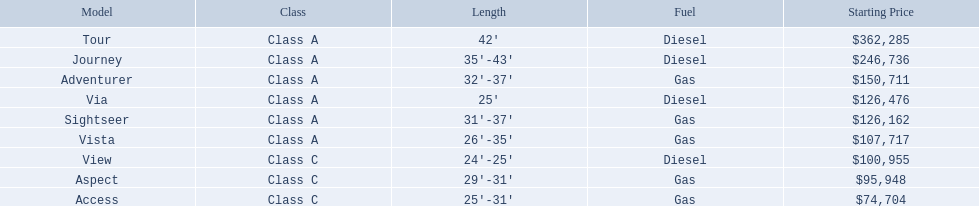What varieties of winnebago models are available? Tour, Journey, Adventurer, Via, Sightseer, Vista, View, Aspect, Access. Which ones are diesel-powered? Tour, Journey, Sightseer, View. Which among them is the most extended? Tour, Journey. Which one has the top starting price? Tour. 